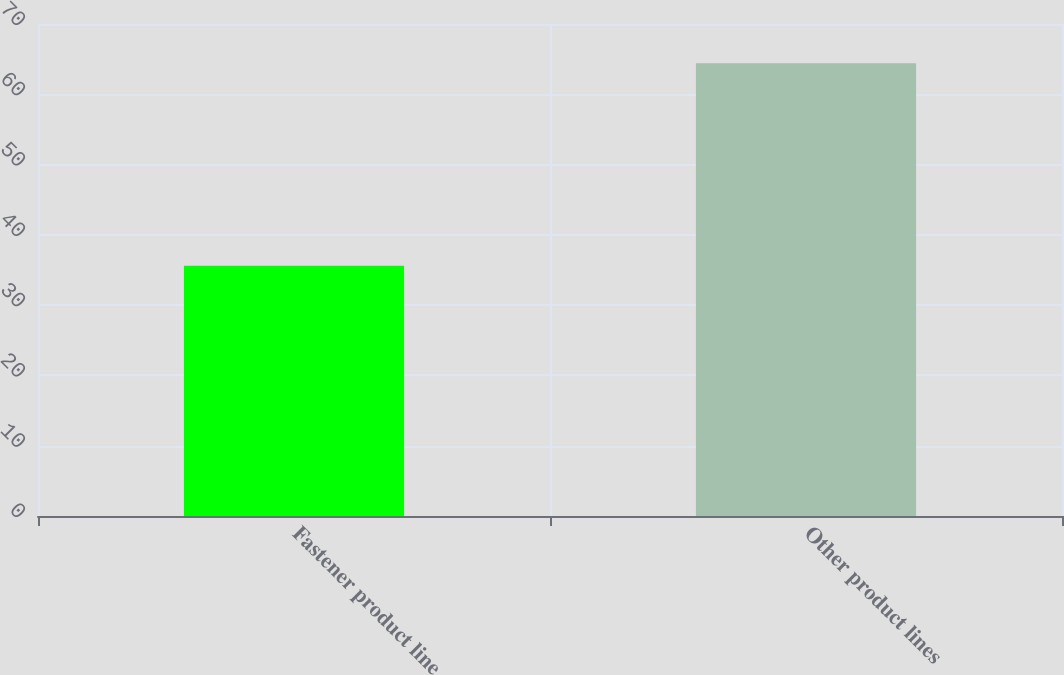Convert chart to OTSL. <chart><loc_0><loc_0><loc_500><loc_500><bar_chart><fcel>Fastener product line<fcel>Other product lines<nl><fcel>35.6<fcel>64.4<nl></chart> 